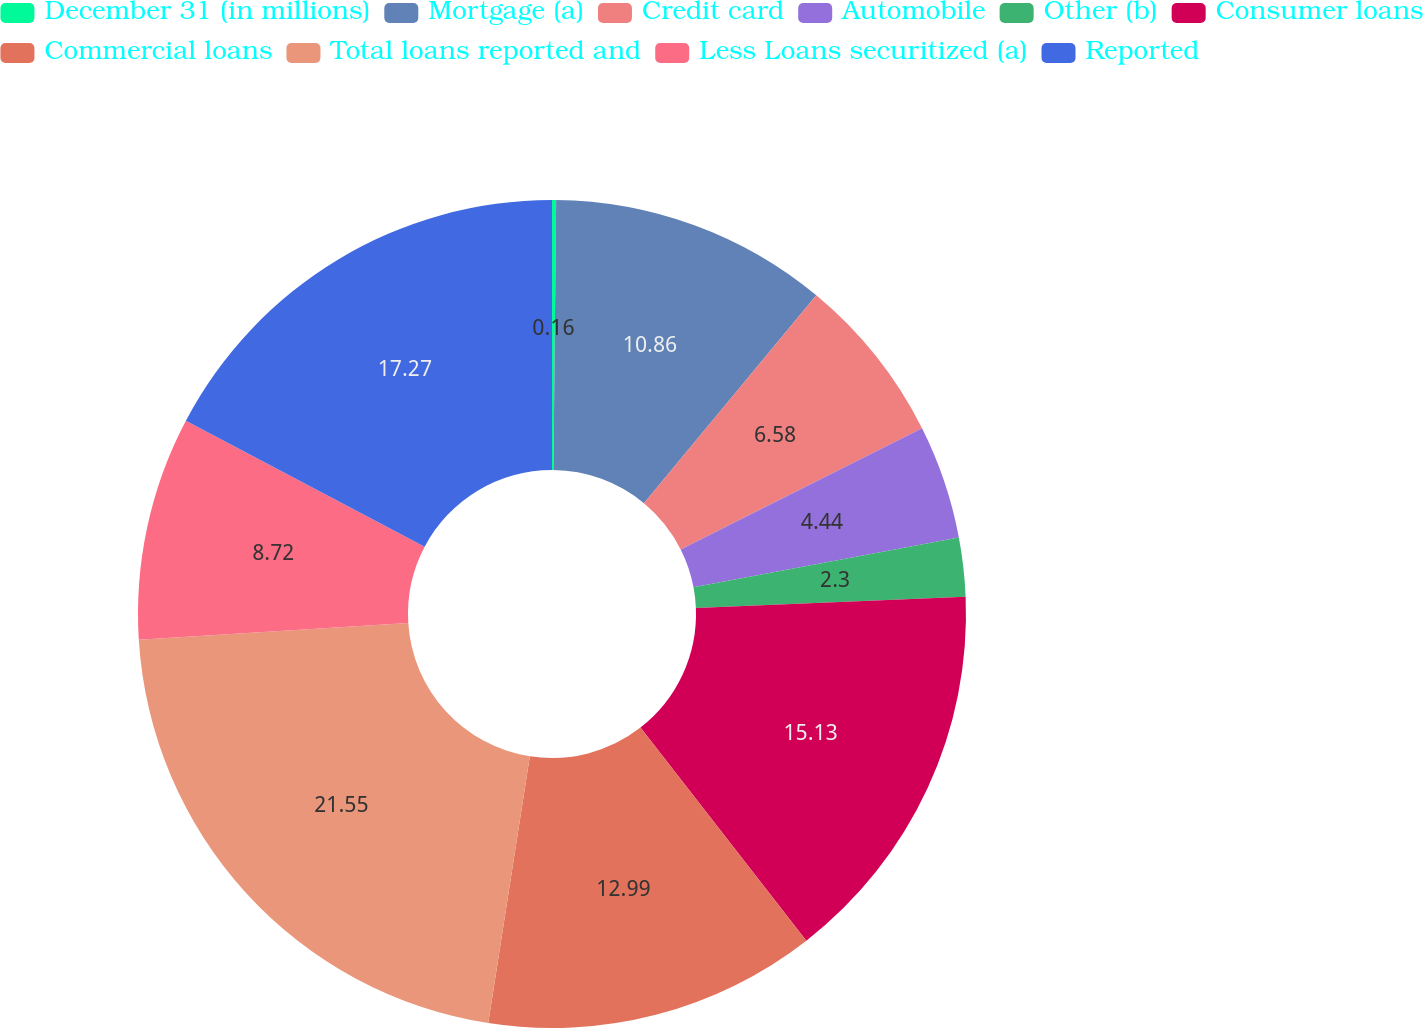Convert chart. <chart><loc_0><loc_0><loc_500><loc_500><pie_chart><fcel>December 31 (in millions)<fcel>Mortgage (a)<fcel>Credit card<fcel>Automobile<fcel>Other (b)<fcel>Consumer loans<fcel>Commercial loans<fcel>Total loans reported and<fcel>Less Loans securitized (a)<fcel>Reported<nl><fcel>0.16%<fcel>10.86%<fcel>6.58%<fcel>4.44%<fcel>2.3%<fcel>15.13%<fcel>12.99%<fcel>21.55%<fcel>8.72%<fcel>17.27%<nl></chart> 